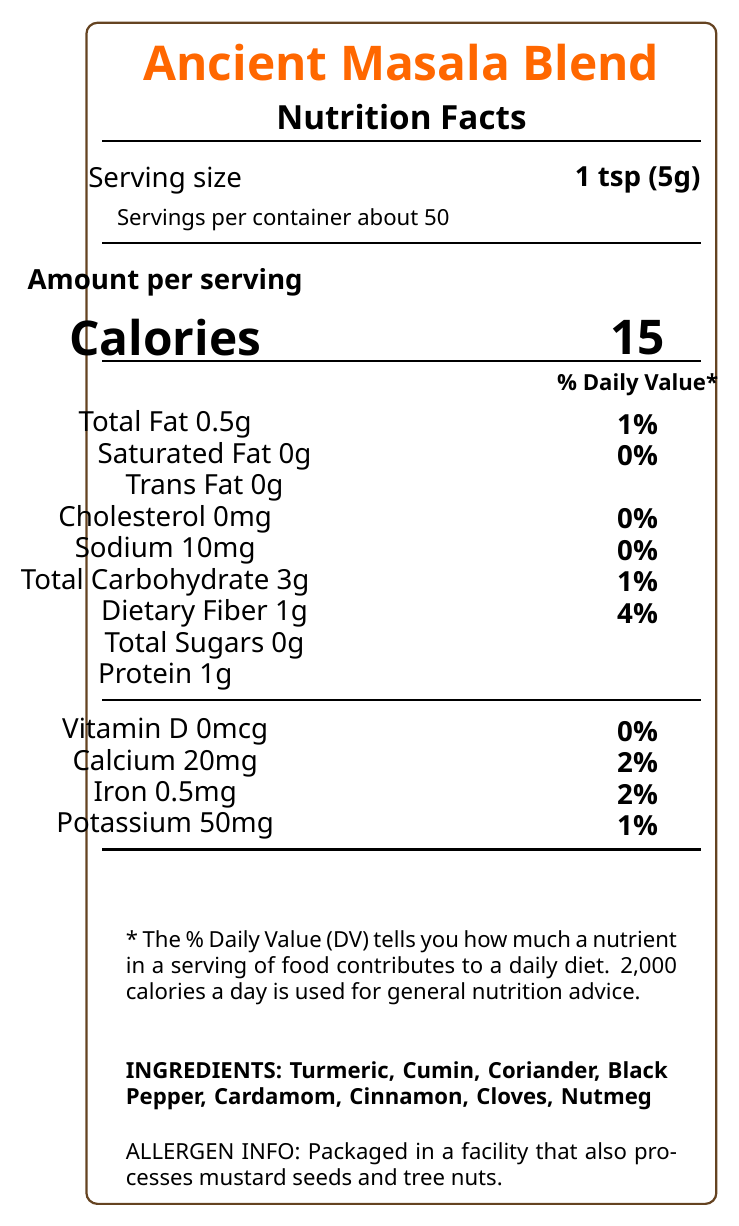what is the serving size of the Ancient Masala Blend? The serving size is directly mentioned in the document under the Nutrition Facts label.
Answer: 1 tsp (5g) how many calories are in one serving of Ancient Masala Blend? The calorie content is listed as "15" directly under the "Calories" section in the document.
Answer: 15 what percentage of the daily value for dietary fiber does one serving of Ancient Masala Blend provide? The percentage of daily value for dietary fiber is listed as "4%" under the "Dietary Fiber" section in the document.
Answer: 4% what is the amount of sodium per serving? The amount of sodium per serving is listed as "10mg" under the "Sodium" section in the document.
Answer: 10mg what are the ingredients in the Ancient Masala Blend? The ingredients are listed at the end of the Nutrition Facts label in the document.
Answer: Turmeric, Cumin, Coriander, Black Pepper, Cardamom, Cinnamon, Cloves, Nutmeg how many servings are there in one container of Ancient Masala Blend? The number of servings per container is listed as "50" under the serving size information.
Answer: 50 what is the total fat content per serving and its daily value percentage? The total fat content is listed as "0.5g" and the daily value percentage as "1%" in the "Total Fat" section of the document.
Answer: 0.5g, 1% which company manufactures the Ancient Masala Blend? The manufacturer information is provided in the document as "Spice Trails of India, Mumbai, Maharashtra."
Answer: Spice Trails of India, Mumbai, Maharashtra is there any trans fat in Ancient Masala Blend? The document lists the trans fat amount as "0g," thus indicating that there is no trans fat.
Answer: No what historical significance does the Ancient Masala Blend hold? The historical significance is explained in the document under the historical significance section.
Answer: This ancient spice blend, known as 'Garam Masala', has been used in Indian cuisine for over 4,000 years. It was first mentioned in the Vedic Sanskrit texts and was believed to have medicinal properties according to Ayurvedic traditions. does Ancient Masala Blend contain any added sugars? The total sugars content is listed as "0g," indicating that there are no added sugars in the blend.
Answer: No summarize the nutritional content and features of the Ancient Masala Blend. This summary encapsulates the primary nutritional content, ingredients, historical significance, and features mentioned in the document.
Answer: The Ancient Masala Blend is a traditional Indian spice mix with a historical significance of over 4,000 years. It contains 15 calories per serving, with low fat, no cholesterol, low sodium, and carbohydrates mainly from dietary fiber. The ingredients include turmeric, cumin, coriander, black pepper, cardamom, cinnamon, cloves, and nutmeg. The blend is rich in historical and cultural value and certified by several food quality standards. based on the nutritional information, can this spice blend be considered high in potassium? The potassium content is listed as "50mg" which is only 1% of the daily value, thus it cannot be considered high in potassium.
Answer: No which of the following spices is NOT an ingredient in the Ancient Masala Blend?
A. Turmeric
B. Ginger
C. Cumin
D. Cardamom Ginger is not listed among the ingredients (Turmeric, Cumin, Coriander, Black Pepper, Cardamom, Cinnamon, Cloves, Nutmeg).
Answer: B. Ginger what certifications does Ancient Masala Blend have?
A. FSSAI Certified 
B. Non-GMO Project Verified 
C. Organic India
D. USDA Organic The certifications listed are "FSSAI Certified," "Non-GMO Project Verified," and "Organic India." USDA Organic is not listed.
Answer: A, B, C does this product contain any cholesterol? The document mentions "Cholesterol 0mg," indicating that the product contains no cholesterol.
Answer: No what is the best way to store Ancient Masala Blend? The storage instructions are explicitly provided in the document.
Answer: Store in a cool, dry place away from direct sunlight. Best used within 6 months of opening for optimal flavor. what is the main use of Ancient Masala Blend in cooking? The document specifies the primary culinary uses of the blend.
Answer: Commonly used in North Indian dishes such as Butter Chicken, Biryani, and various curries. It can also be sprinkled on yogurt or lentil dishes for added flavor. does the Ancient Masala Blend have any Vitamin D content? The Vitamin D content is specified as "0mcg" which means it does not contain any Vitamin D.
Answer: 0mcg how much Vitamin C does one serving of Ancient Masala Blend provide? The document does not provide any information about the Vitamin C content, so the answer cannot be determined.
Answer: Cannot be determined 